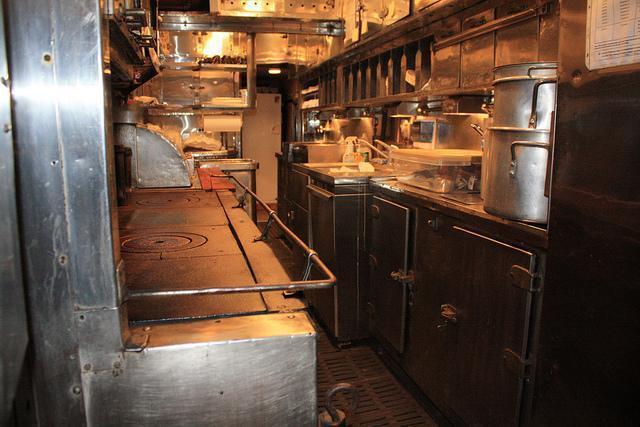What kind of setting is this venue?
Choose the right answer from the provided options to respond to the question.
Options: Laboratory, domestic kitchen, factory, commercial kitchen. Commercial kitchen. 